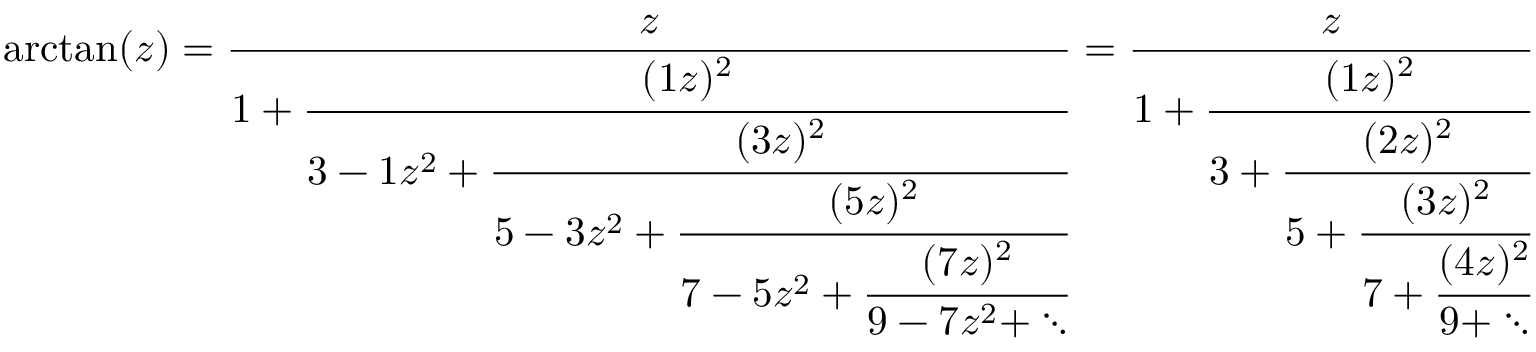<formula> <loc_0><loc_0><loc_500><loc_500>\arctan ( z ) = { \frac { z } { 1 + { \cfrac { ( 1 z ) ^ { 2 } } { 3 - 1 z ^ { 2 } + { \cfrac { ( 3 z ) ^ { 2 } } { 5 - 3 z ^ { 2 } + { \cfrac { ( 5 z ) ^ { 2 } } { 7 - 5 z ^ { 2 } + { \cfrac { ( 7 z ) ^ { 2 } } { 9 - 7 z ^ { 2 } + \ddots } } } } } } } } } } = { \frac { z } { 1 + { \cfrac { ( 1 z ) ^ { 2 } } { 3 + { \cfrac { ( 2 z ) ^ { 2 } } { 5 + { \cfrac { ( 3 z ) ^ { 2 } } { 7 + { \cfrac { ( 4 z ) ^ { 2 } } { 9 + \ddots } } } } } } } } } }</formula> 